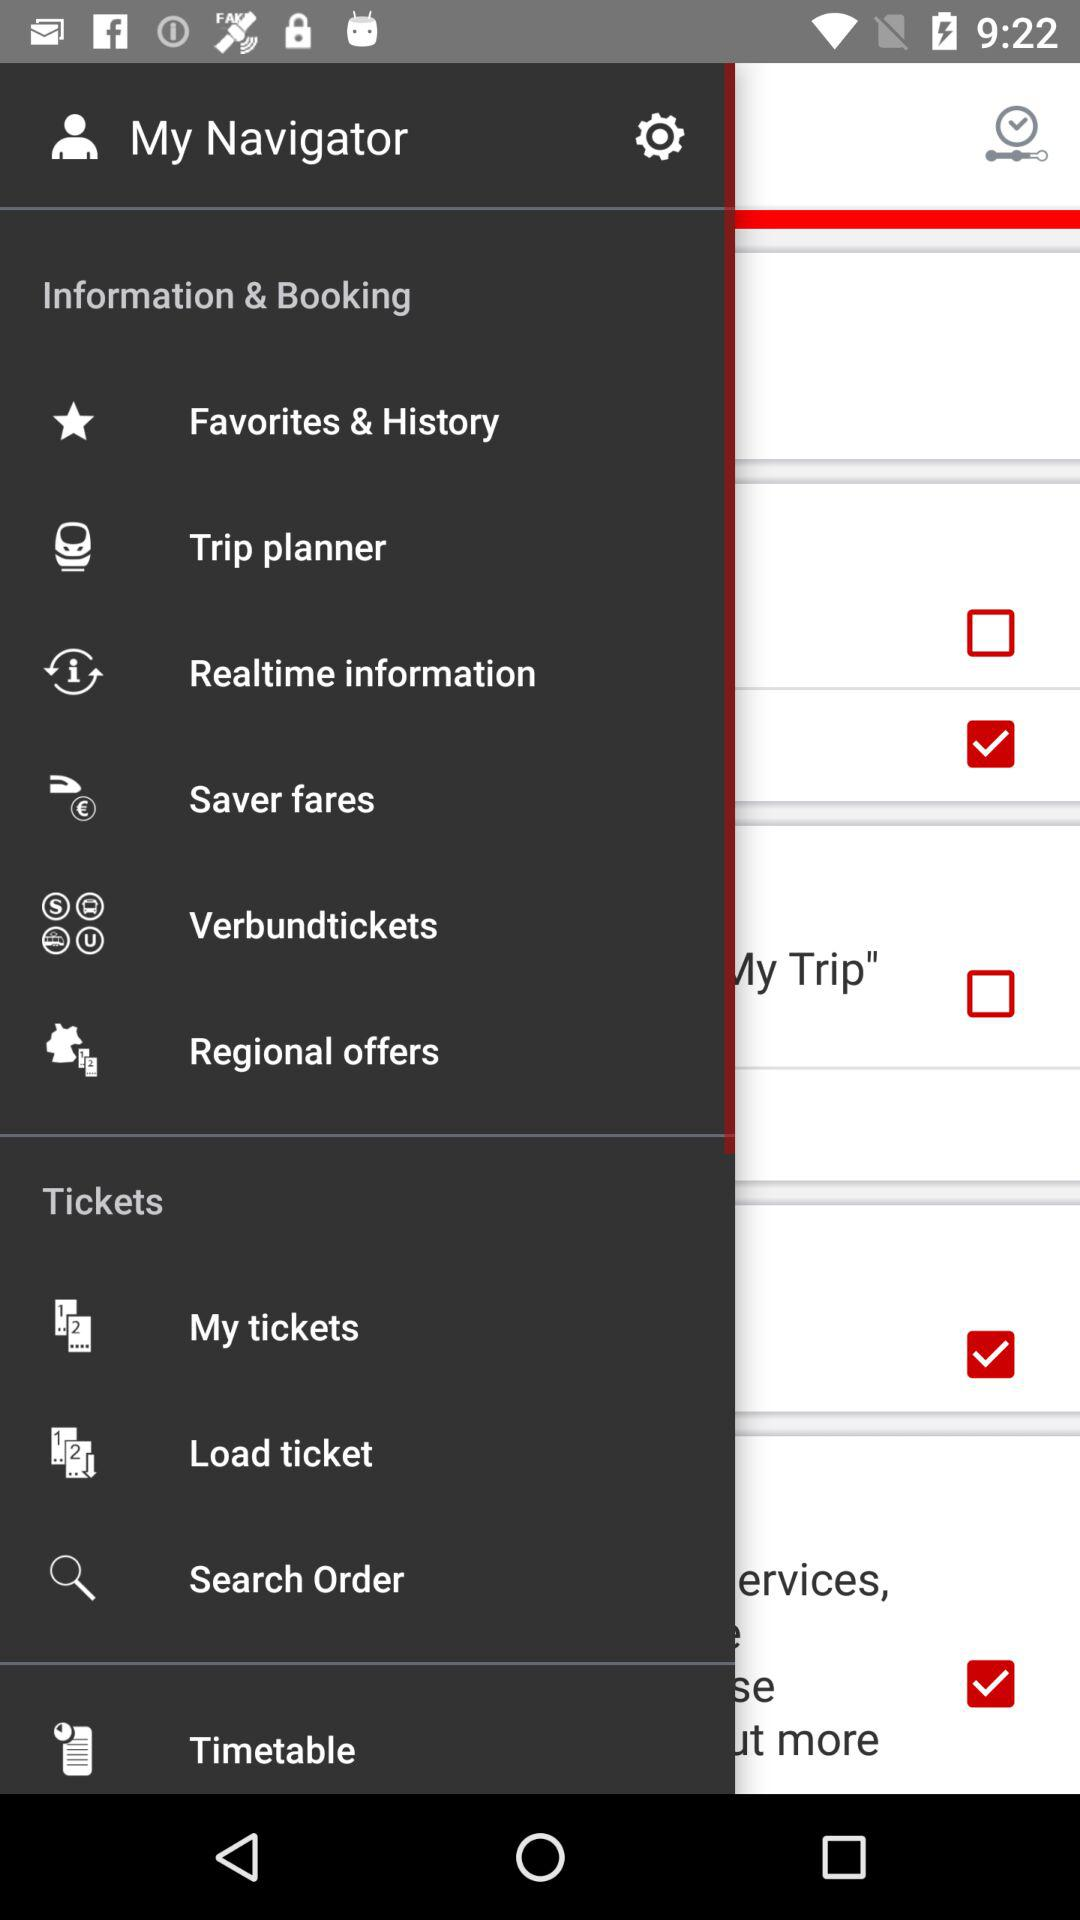How many items have a checkbox next to them?
Answer the question using a single word or phrase. 5 